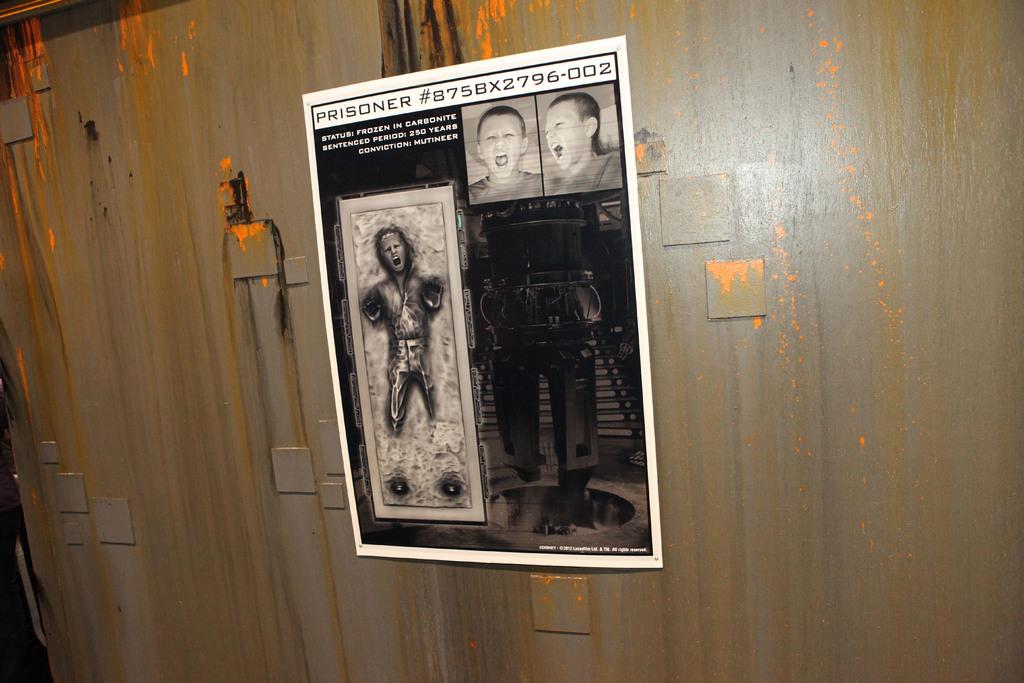What type of number is shown on the picture?
Offer a terse response. 875bx2796-002. 